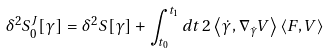<formula> <loc_0><loc_0><loc_500><loc_500>\delta ^ { 2 } S _ { 0 } ^ { J } [ \gamma ] = \delta ^ { 2 } S [ \gamma ] + \int _ { t _ { 0 } } ^ { t _ { 1 } } d t \, 2 \left \langle \dot { \gamma } , \nabla _ { \dot { \gamma } } V \right \rangle \left \langle F , V \right \rangle</formula> 